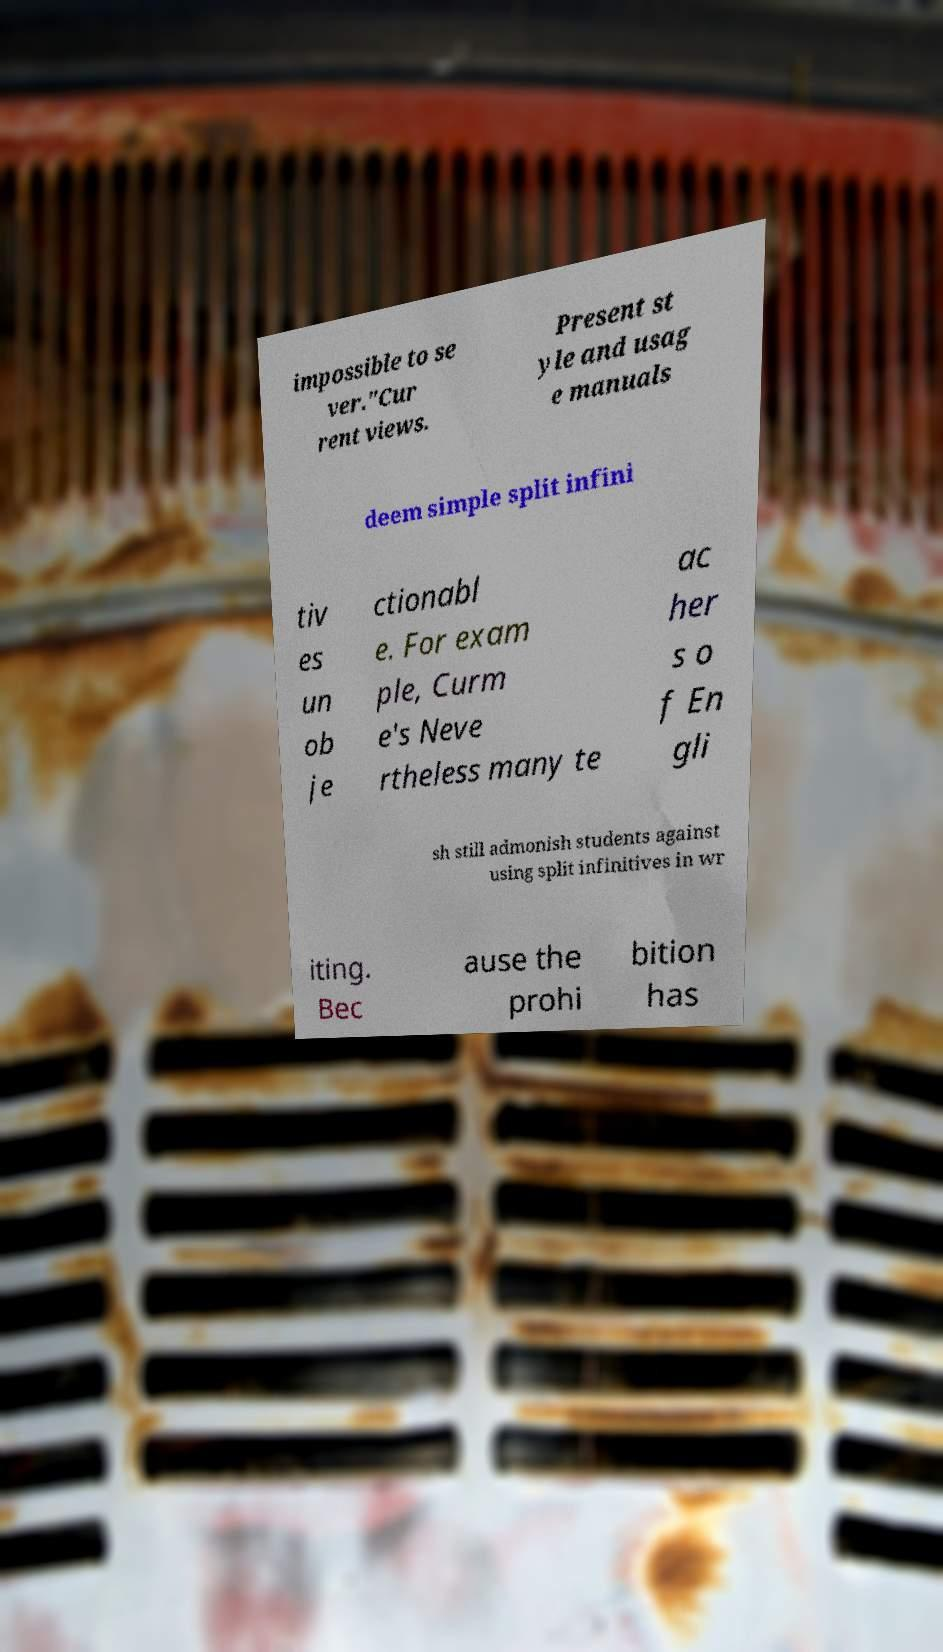Can you accurately transcribe the text from the provided image for me? impossible to se ver."Cur rent views. Present st yle and usag e manuals deem simple split infini tiv es un ob je ctionabl e. For exam ple, Curm e's Neve rtheless many te ac her s o f En gli sh still admonish students against using split infinitives in wr iting. Bec ause the prohi bition has 